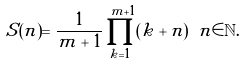Convert formula to latex. <formula><loc_0><loc_0><loc_500><loc_500>S ( n ) = \frac { 1 } { m + 1 } \prod _ { k = 1 } ^ { m + 1 } ( k + n ) \ n \in \mathbb { N } .</formula> 